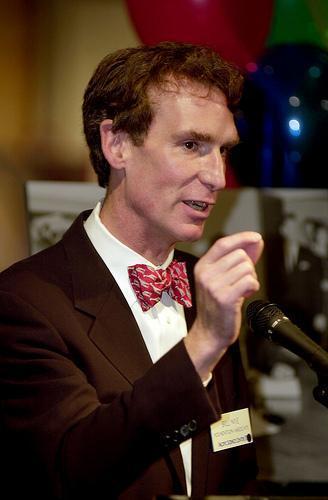How many people are in the picture?
Give a very brief answer. 1. 